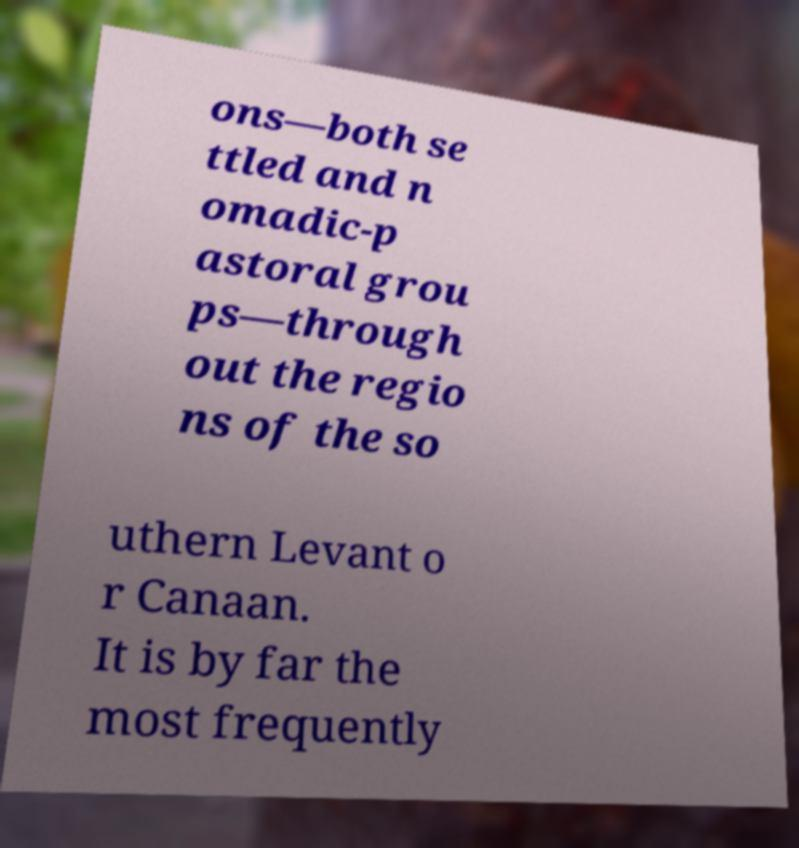Could you assist in decoding the text presented in this image and type it out clearly? ons—both se ttled and n omadic-p astoral grou ps—through out the regio ns of the so uthern Levant o r Canaan. It is by far the most frequently 